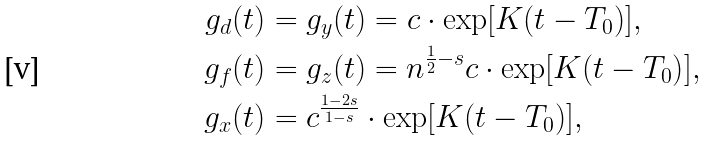<formula> <loc_0><loc_0><loc_500><loc_500>g _ { d } ( t ) & = g _ { y } ( t ) = c \cdot \exp [ { K ( t - T _ { 0 } ) } ] , \\ g _ { f } ( t ) & = g _ { z } ( t ) = n ^ { \frac { 1 } { 2 } - s } c \cdot \exp [ { K ( t - T _ { 0 } ) } ] , \\ g _ { x } ( t ) & = c ^ { \frac { 1 - 2 s } { 1 - s } } \cdot \exp [ { K ( t - T _ { 0 } ) } ] ,</formula> 